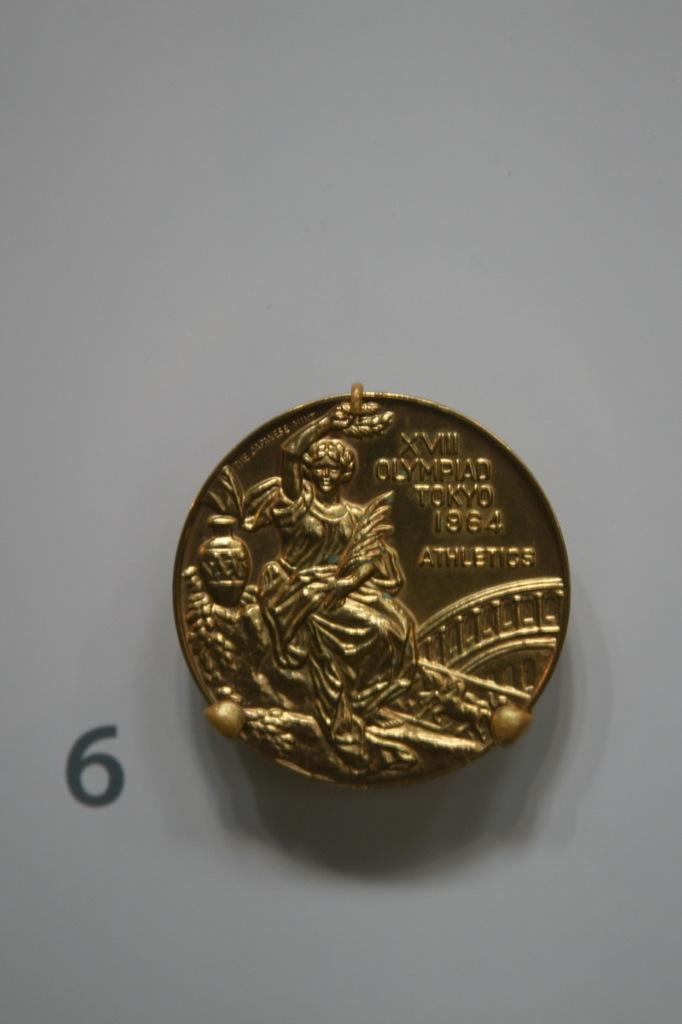Provide a one-sentence caption for the provided image. XVIII Olympiad Tokyo 1964  Athletics gold coin. 